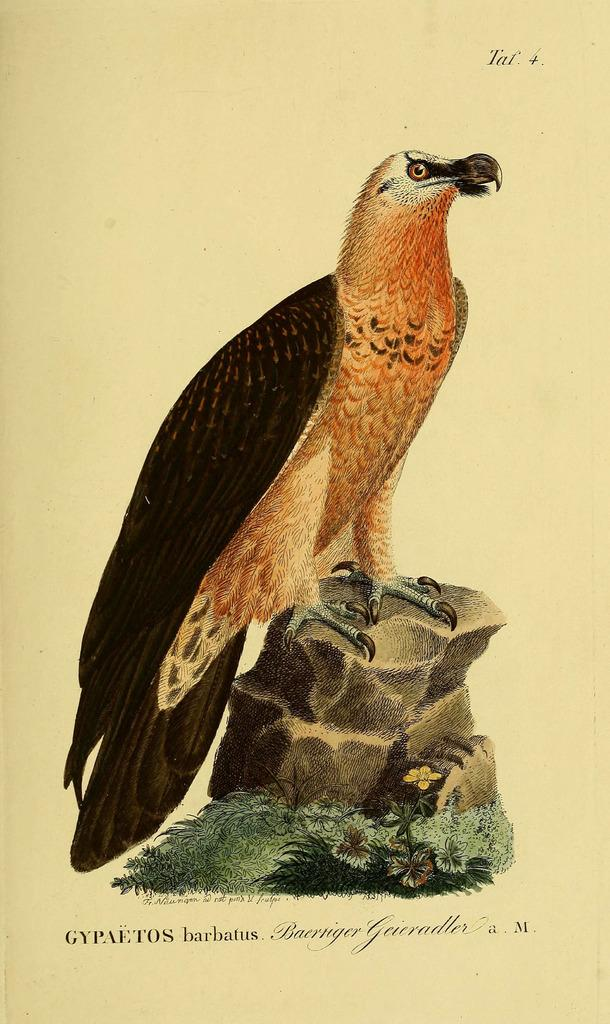What is depicted on the stone in the image? There is a painting of a bird on a stone. What else can be seen near the stone in the image? There are plants near the stone. Is there any text present in the image? Yes, there is text written on the image. Where is the chicken market located in the image? There is no chicken market present in the image. What type of work is the bird doing in the image? The bird is a subject of a painting and is not performing any work in the image. 